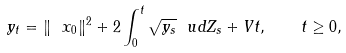<formula> <loc_0><loc_0><loc_500><loc_500>y _ { t } = \| \ x _ { 0 } \| ^ { 2 } + 2 \int _ { 0 } ^ { t } \sqrt { y _ { s } } \ u d Z _ { s } + V t , \quad t \geq 0 ,</formula> 